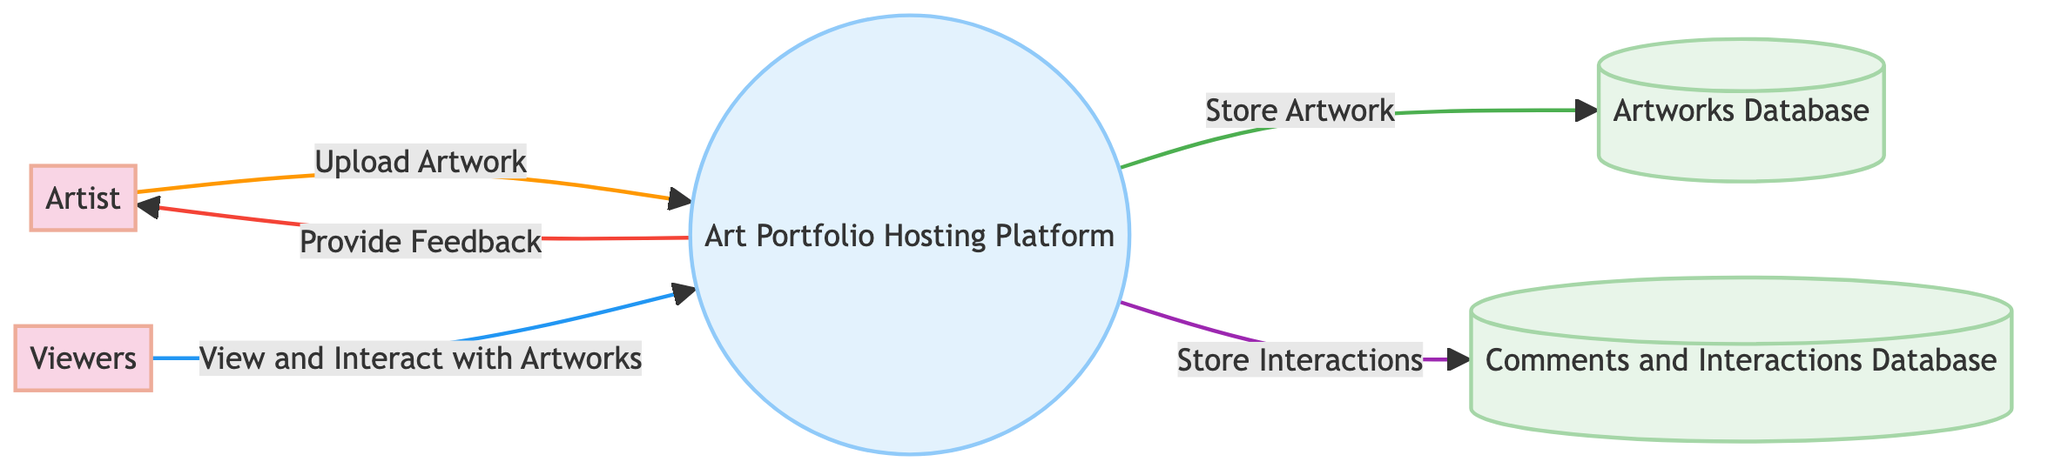What is the main process in the diagram? The main process in the diagram is represented as the central box labeled "Art Portfolio Hosting Platform". It is where all interactions and data flows are primarily focused.
Answer: Art Portfolio Hosting Platform How many external entities are present in the diagram? There are two external entities: "Artist" and "Viewers." Each is depicted with a distinct style to differentiate them from the process and data stores.
Answer: 2 What data does the Artist send to the Art Portfolio Hosting Platform? The Artist provides the data labeled "Upload Artwork," which signifies the action of uploading art pieces along with their descriptions and tags.
Answer: Upload Artwork Which data store is used to store artworks? The data store specifically labeled for storing artworks is called the "Artworks Database." This is shown in the diagram with its respective format as a data store.
Answer: Artworks Database What type of data is stored in the Comments and Interactions Database? The type of data that is stored in the Comments and Interactions Database is derived from interactions such as comments, likes, and shares by viewers.
Answer: Interactions Which external entity receives feedback from the Art Portfolio Hosting Platform? The external entity that receives feedback is the "Artist," who is informed about interactions and views regarding their uploaded artworks.
Answer: Artist What is the purpose of the data flow from the Art Portfolio Hosting Platform to the Artworks Database? The purpose of the data flow labeled "Store Artwork" indicates that the Art Portfolio Hosting Platform stores the uploaded artworks and their metadata into the Artworks Database as part of the processing.
Answer: Store Artwork How do viewers interact with the artworks on the platform? Viewers interact with the artworks by engaging with the platform to "View and Interact with Artworks," which includes actions like commenting, liking, and sharing.
Answer: View and Interact with Artworks What data is sent back from the Art Portfolio Hosting Platform to the Artist? The data sent back from the Art Portfolio Hosting Platform to the Artist is labeled "Provide Feedback," summarizing the interactions and views on their artworks.
Answer: Provide Feedback 